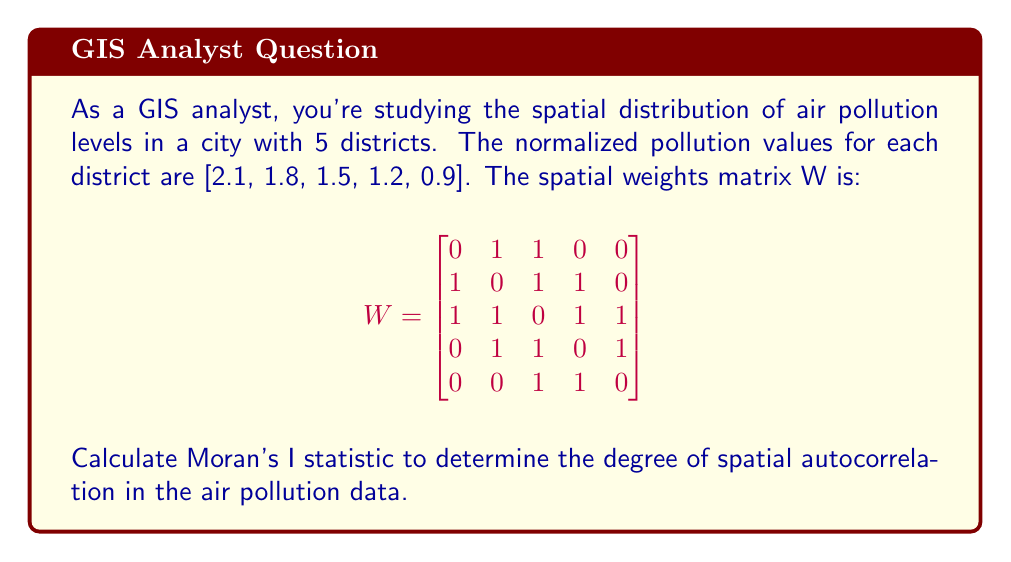Can you answer this question? To calculate Moran's I statistic, we'll follow these steps:

1. Calculate the mean of the pollution values:
   $\bar{x} = \frac{2.1 + 1.8 + 1.5 + 1.2 + 0.9}{5} = 1.5$

2. Calculate the deviations from the mean:
   $z_i = x_i - \bar{x}$
   $z = [0.6, 0.3, 0, -0.3, -0.6]$

3. Calculate the sum of squared deviations:
   $\sum_{i=1}^n z_i^2 = 0.6^2 + 0.3^2 + 0^2 + (-0.3)^2 + (-0.6)^2 = 0.90$

4. Calculate the sum of all weights:
   $S_0 = \sum_{i=1}^n \sum_{j=1}^n w_{ij} = 16$

5. Calculate the numerator of Moran's I:
   $N = \sum_{i=1}^n \sum_{j=1}^n w_{ij}z_i z_j$
   $N = (0.6 \times 0.3 + 0.6 \times 0) + (0.3 \times 0.6 + 0.3 \times 0 + 0.3 \times -0.3) + (0 \times 0.6 + 0 \times 0.3 + 0 \times -0.3 + 0 \times -0.6) + (-0.3 \times 0.3 + -0.3 \times 0 + -0.3 \times -0.6) + (-0.6 \times 0 + -0.6 \times -0.3)$
   $N = 0.18 + 0.09 + 0 + 0.27 + 0.18 = 0.72$

6. Apply the Moran's I formula:
   $I = \frac{n}{S_0} \cdot \frac{\sum_{i=1}^n \sum_{j=1}^n w_{ij}z_i z_j}{\sum_{i=1}^n z_i^2}$
   
   $I = \frac{5}{16} \cdot \frac{0.72}{0.90} = 0.25$

The Moran's I statistic is 0.25, indicating a positive spatial autocorrelation in the air pollution data.
Answer: 0.25 